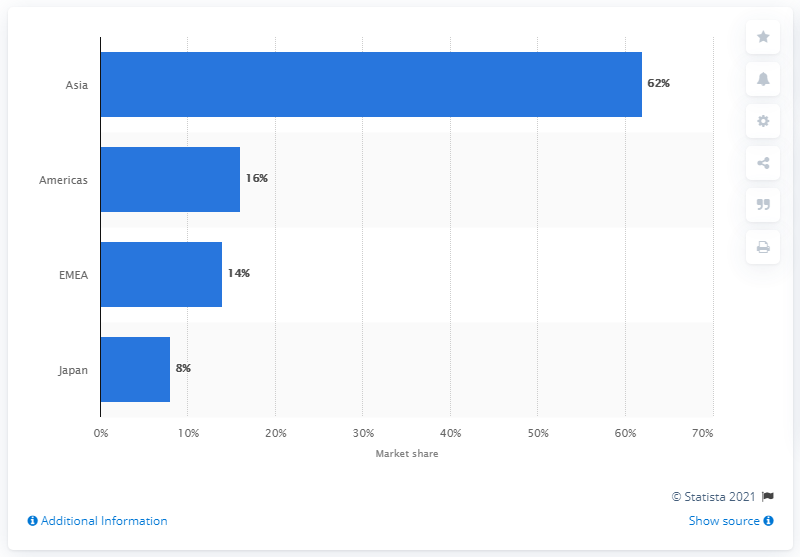Give some essential details in this illustration. In 2015, Asia was the region that accounted for 62% of the global market for electronics components. 